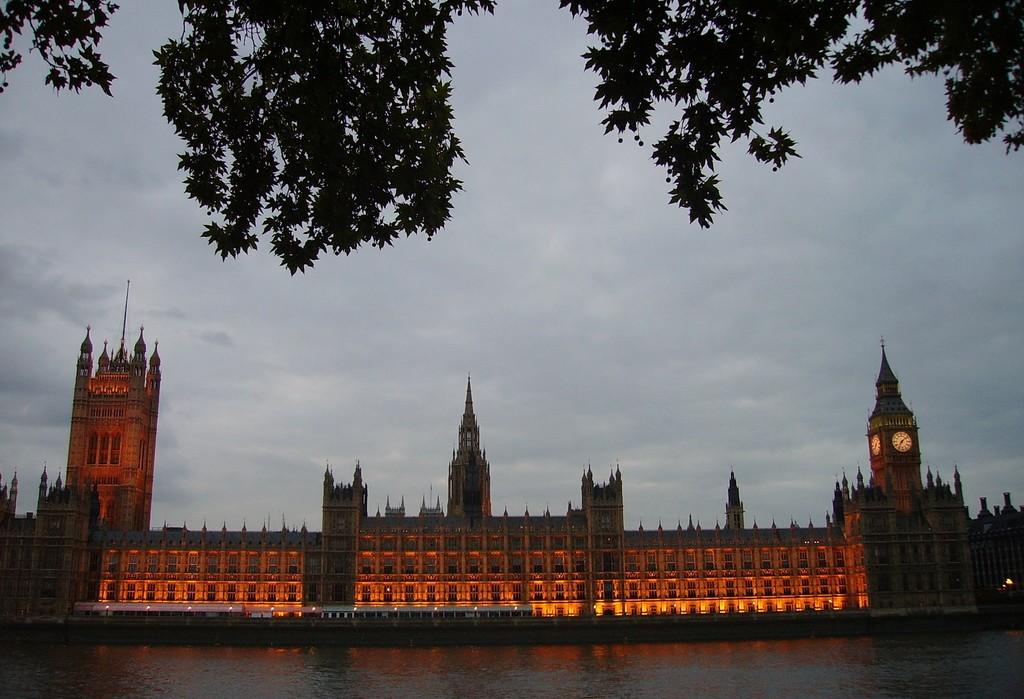What type of structure can be seen in the image? There is a building in the image. What specific feature is present on the building? There is a clock tower in the image. What else can be seen moving in the image? Vehicles are visible in the image. What natural element is present in the image? There is water in the image. What type of vegetation is present in the image? Trees are present in the image. How would you describe the lighting in the image? The image has orange and yellow lighting. What color is the sky in the image? The sky is blue and white in color. Where is the cake located in the image? There is no cake present in the image. How many ducks are swimming in the water in the image? There are no ducks present in the image. 